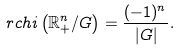<formula> <loc_0><loc_0><loc_500><loc_500>\ r c h i \left ( \mathbb { R } _ { + } ^ { n } / G \right ) = \frac { ( - 1 ) ^ { n } } { | G | } .</formula> 